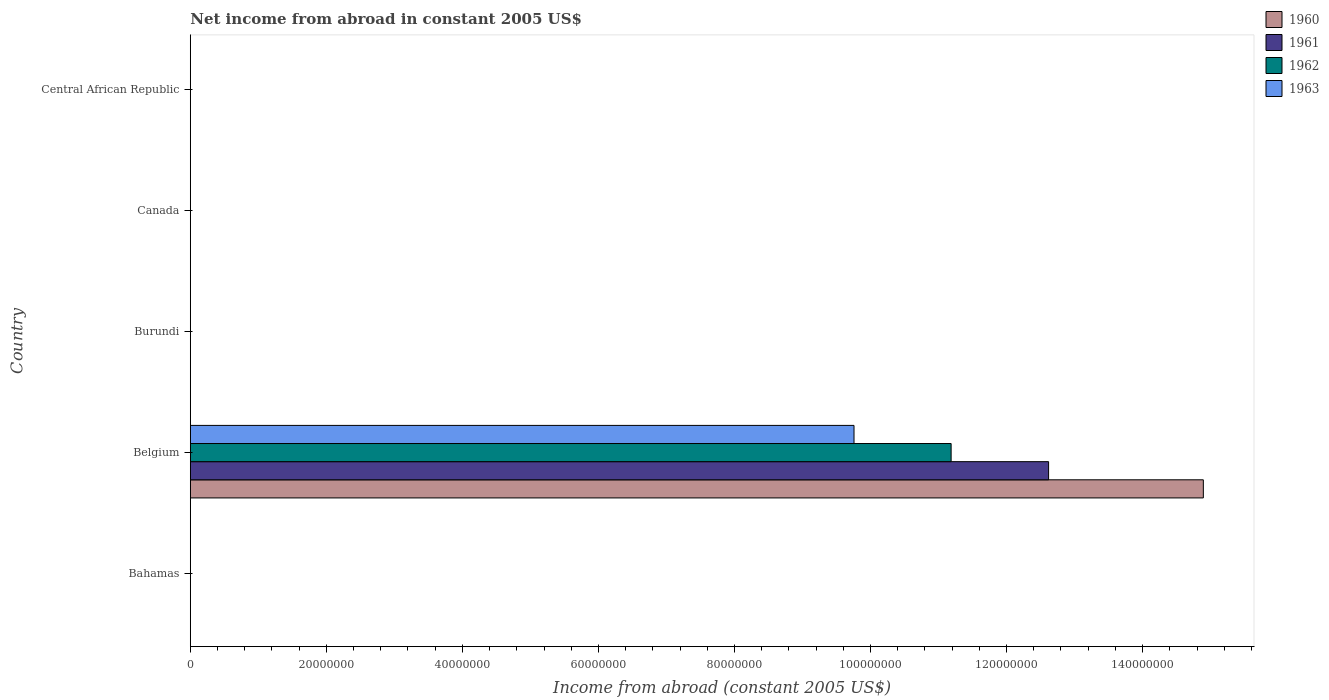How many different coloured bars are there?
Your response must be concise. 4. Are the number of bars per tick equal to the number of legend labels?
Provide a succinct answer. No. How many bars are there on the 3rd tick from the top?
Offer a terse response. 0. How many bars are there on the 3rd tick from the bottom?
Provide a short and direct response. 0. What is the label of the 5th group of bars from the top?
Offer a terse response. Bahamas. In how many cases, is the number of bars for a given country not equal to the number of legend labels?
Ensure brevity in your answer.  4. Across all countries, what is the maximum net income from abroad in 1960?
Offer a terse response. 1.49e+08. Across all countries, what is the minimum net income from abroad in 1961?
Provide a short and direct response. 0. What is the total net income from abroad in 1962 in the graph?
Your answer should be very brief. 1.12e+08. What is the difference between the net income from abroad in 1961 in Central African Republic and the net income from abroad in 1960 in Canada?
Give a very brief answer. 0. What is the average net income from abroad in 1960 per country?
Provide a short and direct response. 2.98e+07. In how many countries, is the net income from abroad in 1960 greater than 72000000 US$?
Give a very brief answer. 1. What is the difference between the highest and the lowest net income from abroad in 1963?
Provide a succinct answer. 9.76e+07. Is it the case that in every country, the sum of the net income from abroad in 1960 and net income from abroad in 1963 is greater than the sum of net income from abroad in 1961 and net income from abroad in 1962?
Your answer should be very brief. No. Is it the case that in every country, the sum of the net income from abroad in 1961 and net income from abroad in 1960 is greater than the net income from abroad in 1962?
Keep it short and to the point. No. How many countries are there in the graph?
Offer a terse response. 5. Does the graph contain grids?
Your answer should be compact. No. How are the legend labels stacked?
Keep it short and to the point. Vertical. What is the title of the graph?
Your answer should be very brief. Net income from abroad in constant 2005 US$. What is the label or title of the X-axis?
Your answer should be compact. Income from abroad (constant 2005 US$). What is the Income from abroad (constant 2005 US$) of 1960 in Bahamas?
Keep it short and to the point. 0. What is the Income from abroad (constant 2005 US$) of 1961 in Bahamas?
Keep it short and to the point. 0. What is the Income from abroad (constant 2005 US$) of 1962 in Bahamas?
Give a very brief answer. 0. What is the Income from abroad (constant 2005 US$) in 1963 in Bahamas?
Provide a short and direct response. 0. What is the Income from abroad (constant 2005 US$) of 1960 in Belgium?
Make the answer very short. 1.49e+08. What is the Income from abroad (constant 2005 US$) of 1961 in Belgium?
Give a very brief answer. 1.26e+08. What is the Income from abroad (constant 2005 US$) in 1962 in Belgium?
Give a very brief answer. 1.12e+08. What is the Income from abroad (constant 2005 US$) of 1963 in Belgium?
Ensure brevity in your answer.  9.76e+07. What is the Income from abroad (constant 2005 US$) in 1960 in Burundi?
Make the answer very short. 0. What is the Income from abroad (constant 2005 US$) of 1963 in Burundi?
Make the answer very short. 0. What is the Income from abroad (constant 2005 US$) of 1960 in Canada?
Provide a succinct answer. 0. What is the Income from abroad (constant 2005 US$) in 1960 in Central African Republic?
Keep it short and to the point. 0. What is the Income from abroad (constant 2005 US$) of 1961 in Central African Republic?
Offer a very short reply. 0. What is the Income from abroad (constant 2005 US$) in 1962 in Central African Republic?
Your answer should be very brief. 0. What is the Income from abroad (constant 2005 US$) in 1963 in Central African Republic?
Provide a succinct answer. 0. Across all countries, what is the maximum Income from abroad (constant 2005 US$) in 1960?
Your answer should be very brief. 1.49e+08. Across all countries, what is the maximum Income from abroad (constant 2005 US$) in 1961?
Offer a terse response. 1.26e+08. Across all countries, what is the maximum Income from abroad (constant 2005 US$) of 1962?
Offer a terse response. 1.12e+08. Across all countries, what is the maximum Income from abroad (constant 2005 US$) in 1963?
Your answer should be very brief. 9.76e+07. Across all countries, what is the minimum Income from abroad (constant 2005 US$) of 1963?
Make the answer very short. 0. What is the total Income from abroad (constant 2005 US$) in 1960 in the graph?
Provide a short and direct response. 1.49e+08. What is the total Income from abroad (constant 2005 US$) in 1961 in the graph?
Your answer should be compact. 1.26e+08. What is the total Income from abroad (constant 2005 US$) of 1962 in the graph?
Your response must be concise. 1.12e+08. What is the total Income from abroad (constant 2005 US$) of 1963 in the graph?
Provide a succinct answer. 9.76e+07. What is the average Income from abroad (constant 2005 US$) in 1960 per country?
Ensure brevity in your answer.  2.98e+07. What is the average Income from abroad (constant 2005 US$) in 1961 per country?
Your answer should be very brief. 2.52e+07. What is the average Income from abroad (constant 2005 US$) in 1962 per country?
Give a very brief answer. 2.24e+07. What is the average Income from abroad (constant 2005 US$) of 1963 per country?
Provide a succinct answer. 1.95e+07. What is the difference between the Income from abroad (constant 2005 US$) in 1960 and Income from abroad (constant 2005 US$) in 1961 in Belgium?
Your answer should be very brief. 2.27e+07. What is the difference between the Income from abroad (constant 2005 US$) in 1960 and Income from abroad (constant 2005 US$) in 1962 in Belgium?
Give a very brief answer. 3.71e+07. What is the difference between the Income from abroad (constant 2005 US$) in 1960 and Income from abroad (constant 2005 US$) in 1963 in Belgium?
Keep it short and to the point. 5.14e+07. What is the difference between the Income from abroad (constant 2005 US$) of 1961 and Income from abroad (constant 2005 US$) of 1962 in Belgium?
Your response must be concise. 1.43e+07. What is the difference between the Income from abroad (constant 2005 US$) in 1961 and Income from abroad (constant 2005 US$) in 1963 in Belgium?
Your response must be concise. 2.86e+07. What is the difference between the Income from abroad (constant 2005 US$) in 1962 and Income from abroad (constant 2005 US$) in 1963 in Belgium?
Keep it short and to the point. 1.43e+07. What is the difference between the highest and the lowest Income from abroad (constant 2005 US$) in 1960?
Provide a short and direct response. 1.49e+08. What is the difference between the highest and the lowest Income from abroad (constant 2005 US$) in 1961?
Your response must be concise. 1.26e+08. What is the difference between the highest and the lowest Income from abroad (constant 2005 US$) in 1962?
Offer a very short reply. 1.12e+08. What is the difference between the highest and the lowest Income from abroad (constant 2005 US$) in 1963?
Ensure brevity in your answer.  9.76e+07. 